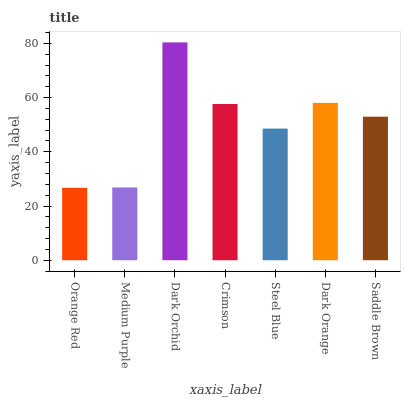Is Orange Red the minimum?
Answer yes or no. Yes. Is Dark Orchid the maximum?
Answer yes or no. Yes. Is Medium Purple the minimum?
Answer yes or no. No. Is Medium Purple the maximum?
Answer yes or no. No. Is Medium Purple greater than Orange Red?
Answer yes or no. Yes. Is Orange Red less than Medium Purple?
Answer yes or no. Yes. Is Orange Red greater than Medium Purple?
Answer yes or no. No. Is Medium Purple less than Orange Red?
Answer yes or no. No. Is Saddle Brown the high median?
Answer yes or no. Yes. Is Saddle Brown the low median?
Answer yes or no. Yes. Is Dark Orange the high median?
Answer yes or no. No. Is Medium Purple the low median?
Answer yes or no. No. 